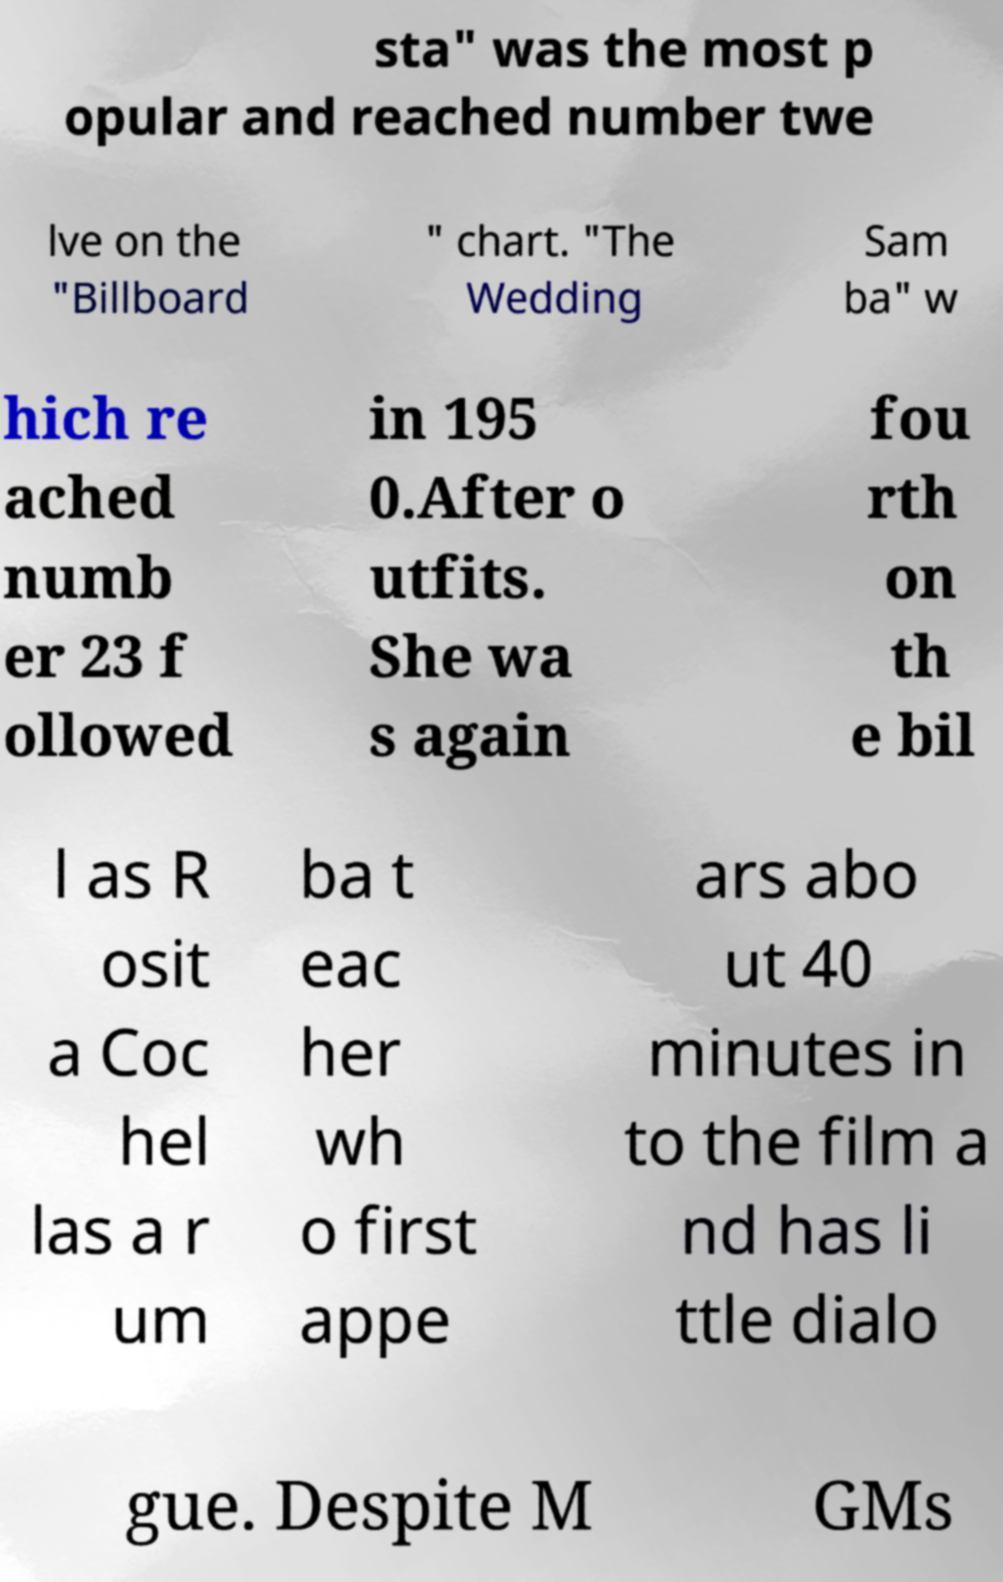Please identify and transcribe the text found in this image. sta" was the most p opular and reached number twe lve on the "Billboard " chart. "The Wedding Sam ba" w hich re ached numb er 23 f ollowed in 195 0.After o utfits. She wa s again fou rth on th e bil l as R osit a Coc hel las a r um ba t eac her wh o first appe ars abo ut 40 minutes in to the film a nd has li ttle dialo gue. Despite M GMs 